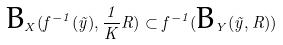<formula> <loc_0><loc_0><loc_500><loc_500>\text {B} _ { X } ( f ^ { - 1 } ( \tilde { y } ) , \frac { 1 } { K } R ) \subset f ^ { - 1 } ( \text {B} _ { Y } ( \tilde { y } , R ) )</formula> 